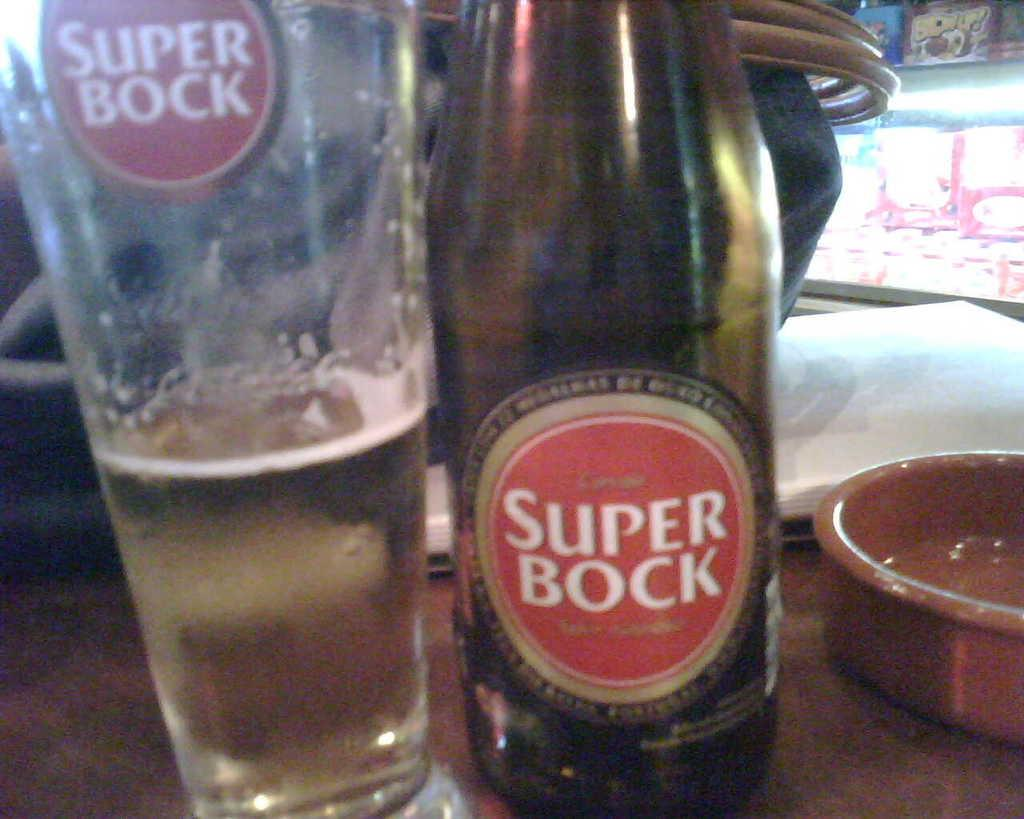<image>
Present a compact description of the photo's key features. A bottle of Super Bock beer sits next to a dish and a glass of beer. 